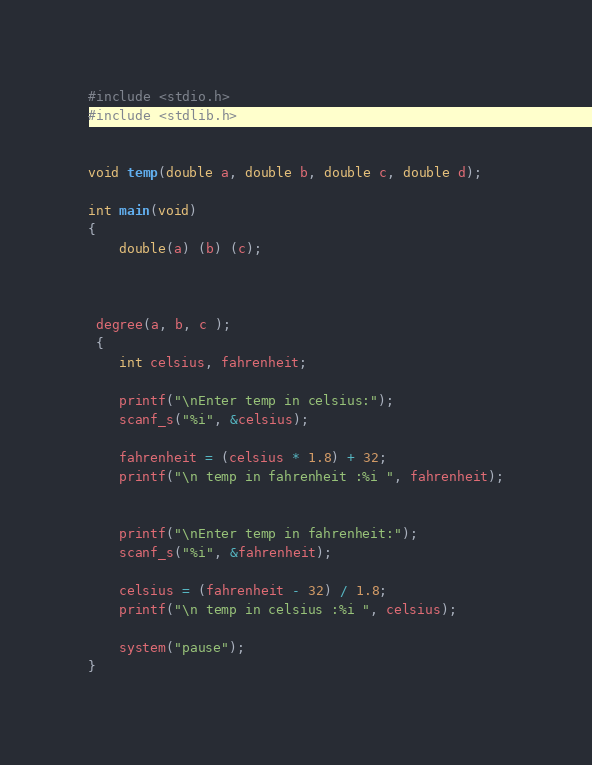<code> <loc_0><loc_0><loc_500><loc_500><_C_>#include <stdio.h>
#include <stdlib.h>
 

void temp(double a, double b, double c, double d);

int main(void)
{
	double(a) (b) (c);



 degree(a, b, c );
 {
	int celsius, fahrenheit;

	printf("\nEnter temp in celsius:");
	scanf_s("%i", &celsius);

	fahrenheit = (celsius * 1.8) + 32;
	printf("\n temp in fahrenheit :%i ", fahrenheit);


	printf("\nEnter temp in fahrenheit:");
	scanf_s("%i", &fahrenheit);

	celsius = (fahrenheit - 32) / 1.8;
	printf("\n temp in celsius :%i ", celsius);

	system("pause");
}


</code> 